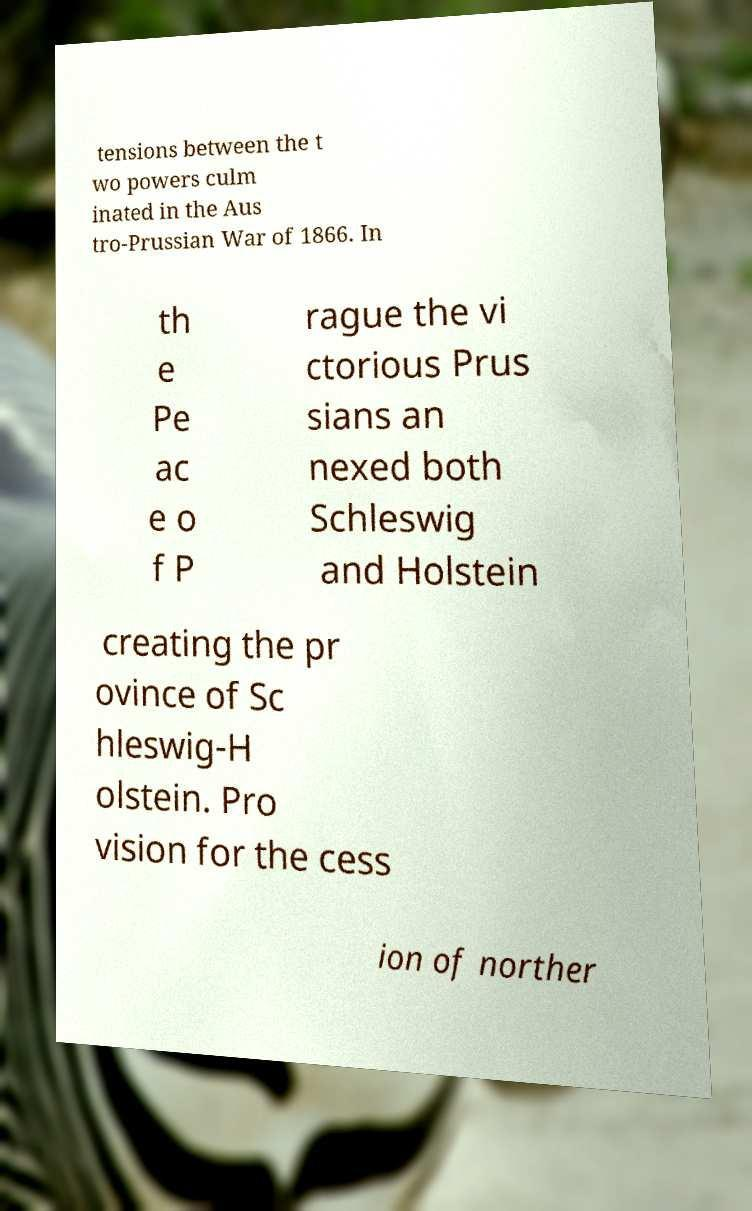There's text embedded in this image that I need extracted. Can you transcribe it verbatim? tensions between the t wo powers culm inated in the Aus tro-Prussian War of 1866. In th e Pe ac e o f P rague the vi ctorious Prus sians an nexed both Schleswig and Holstein creating the pr ovince of Sc hleswig-H olstein. Pro vision for the cess ion of norther 